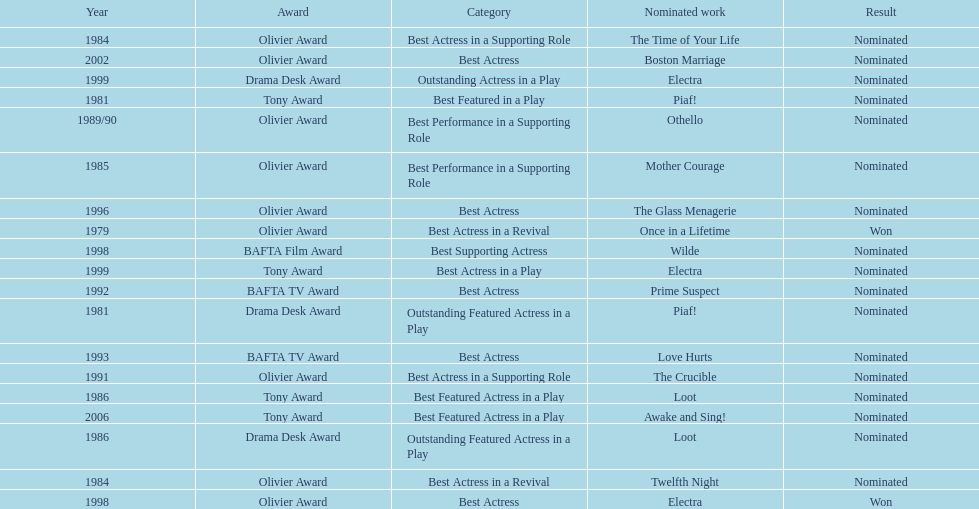What play was wanamaker nominated for best actress in a revival in 1984? Twelfth Night. 